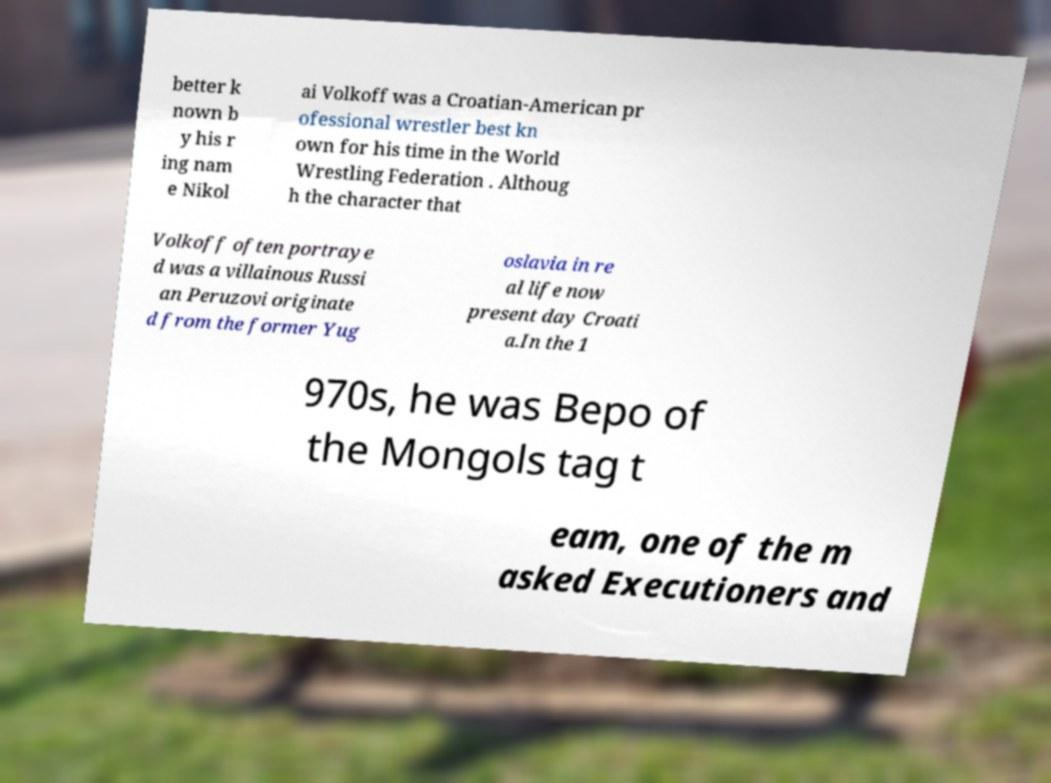I need the written content from this picture converted into text. Can you do that? better k nown b y his r ing nam e Nikol ai Volkoff was a Croatian-American pr ofessional wrestler best kn own for his time in the World Wrestling Federation . Althoug h the character that Volkoff often portraye d was a villainous Russi an Peruzovi originate d from the former Yug oslavia in re al life now present day Croati a.In the 1 970s, he was Bepo of the Mongols tag t eam, one of the m asked Executioners and 